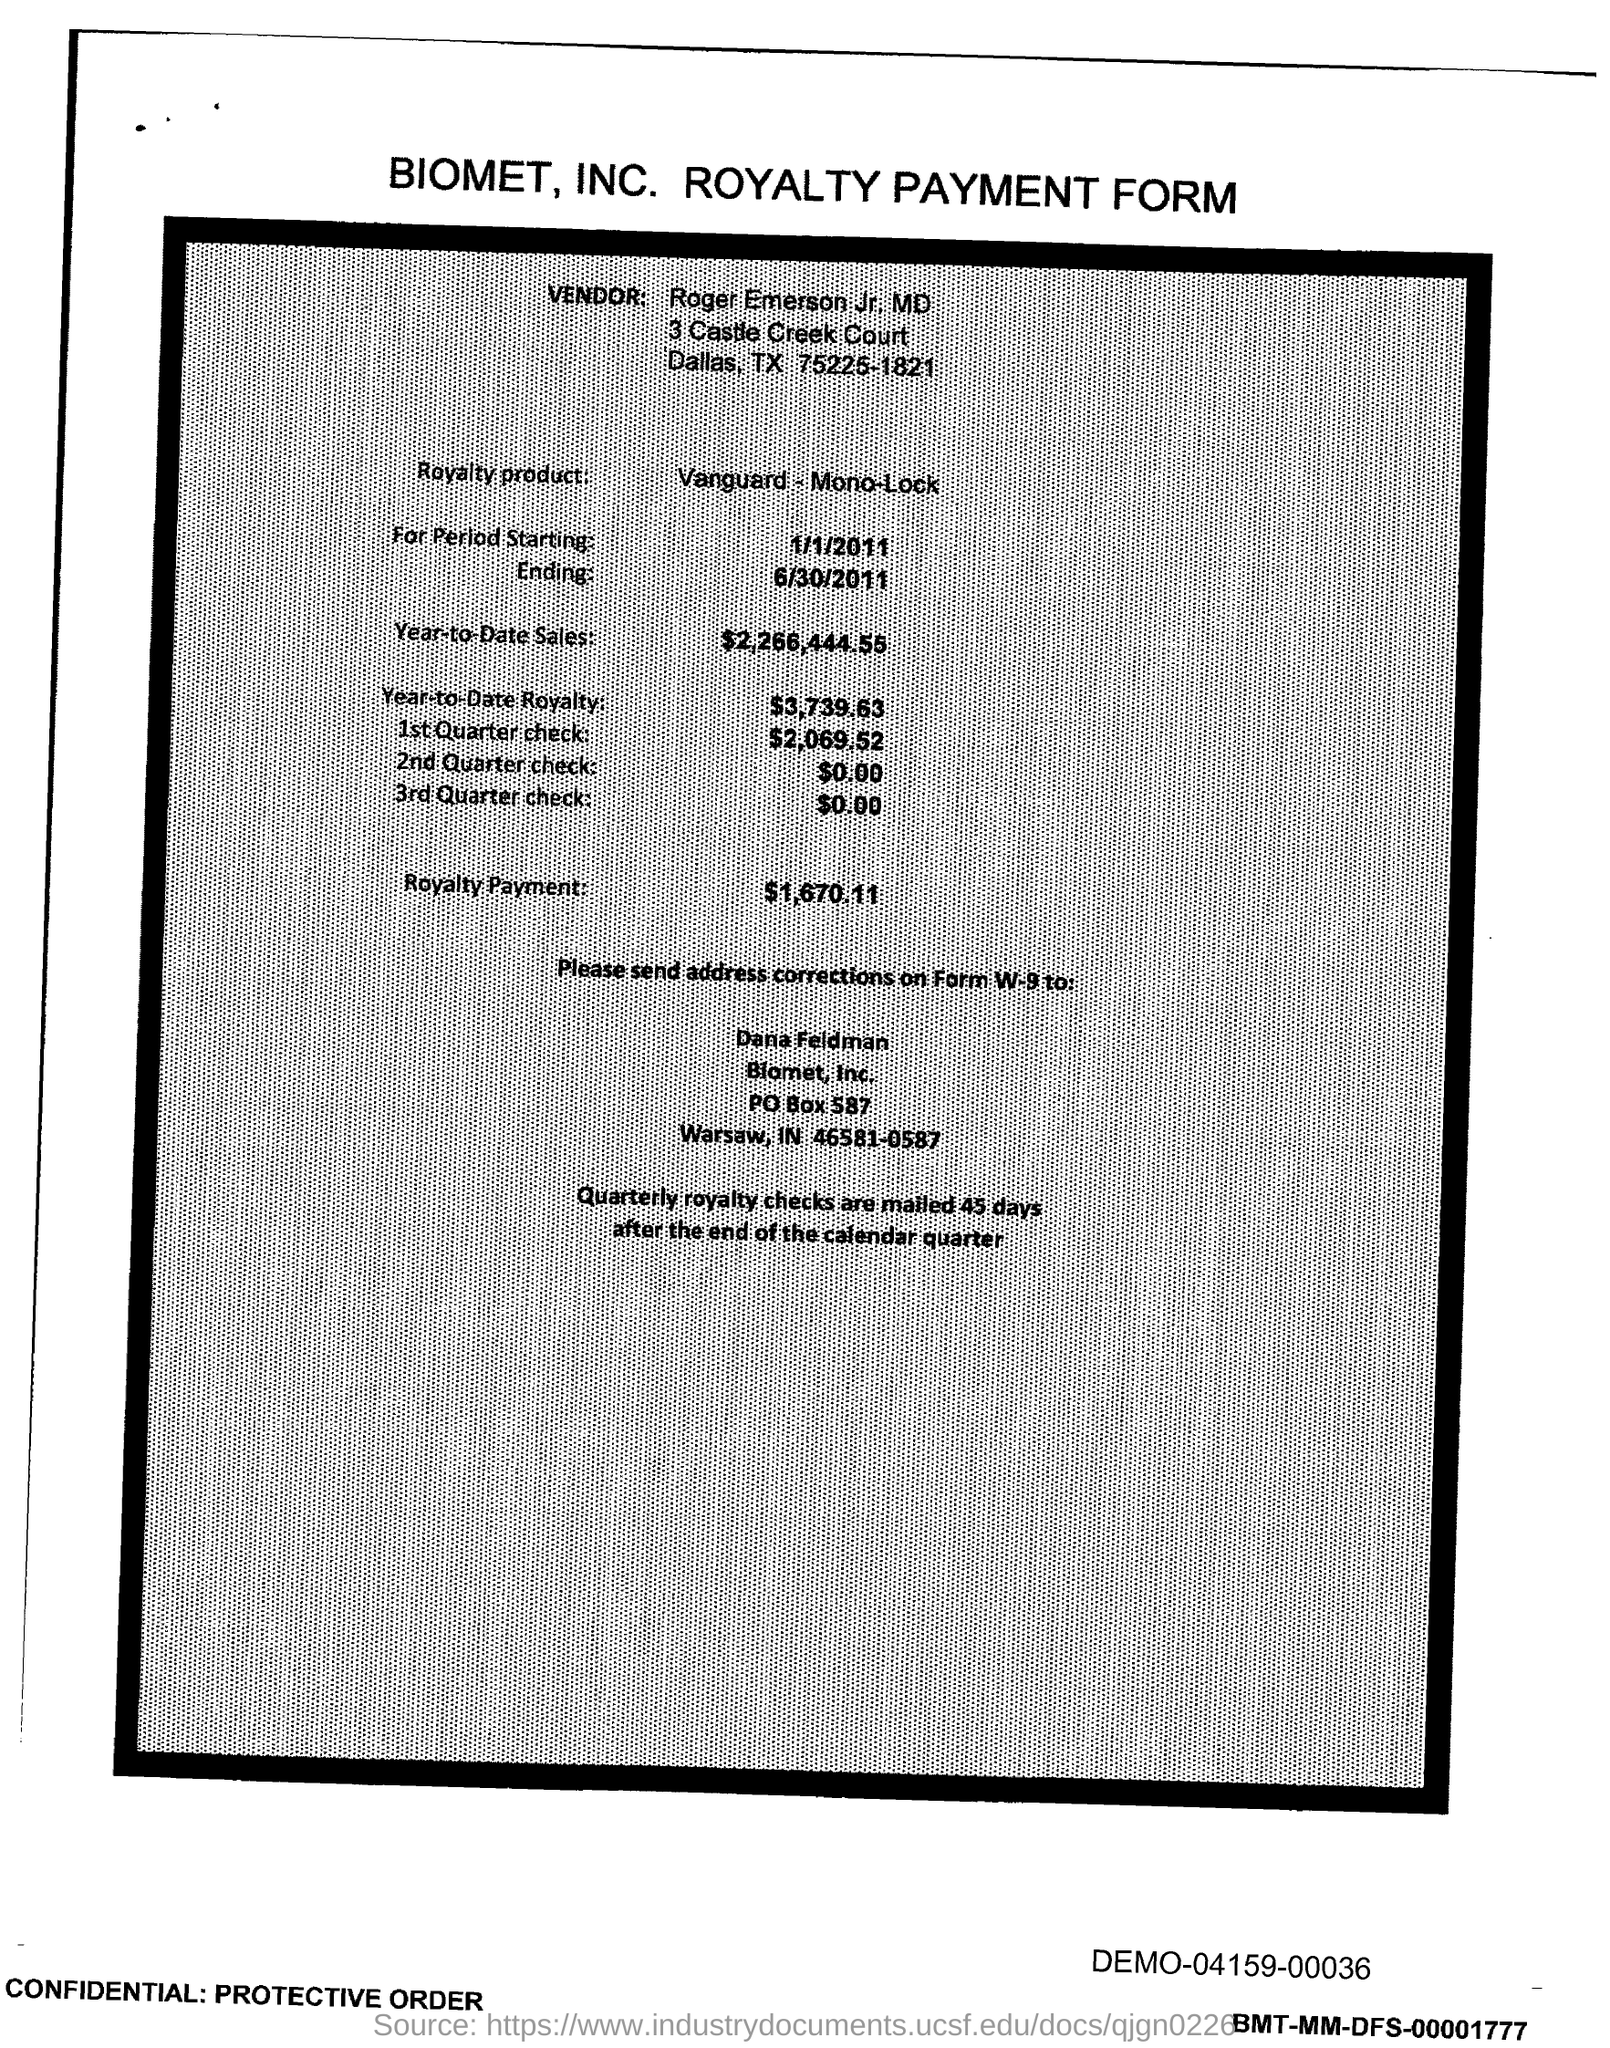Which company's royalty payment form is this?
Keep it short and to the point. Biomet. Who is the vendor mentioned in the form?
Ensure brevity in your answer.  Roger Emerson. What is the royalty product given in the form?
Offer a terse response. Vanguard - mono - lock. What is the Year-to-Date Sales of the royalty product?
Offer a very short reply. $2,266,444.55. What is the Year-to-Date royalty of the product?
Keep it short and to the point. $3,739.63. What is the amount of 3rd Quarter check given in the form?
Provide a short and direct response. 0. What is the amount of 2nd Quarter check mentioned in the form?
Keep it short and to the point. 0. What is the amount of 1st quarter check mentioned in the form?
Your response must be concise. $2,069.52. What is the royalty payment amount of the product?
Offer a terse response. 1,670.11. When are the quartely royalty checks mailed?
Provide a succinct answer. Quarterly royalty checks are mailed 45 days after the end of the calendar quarter. 